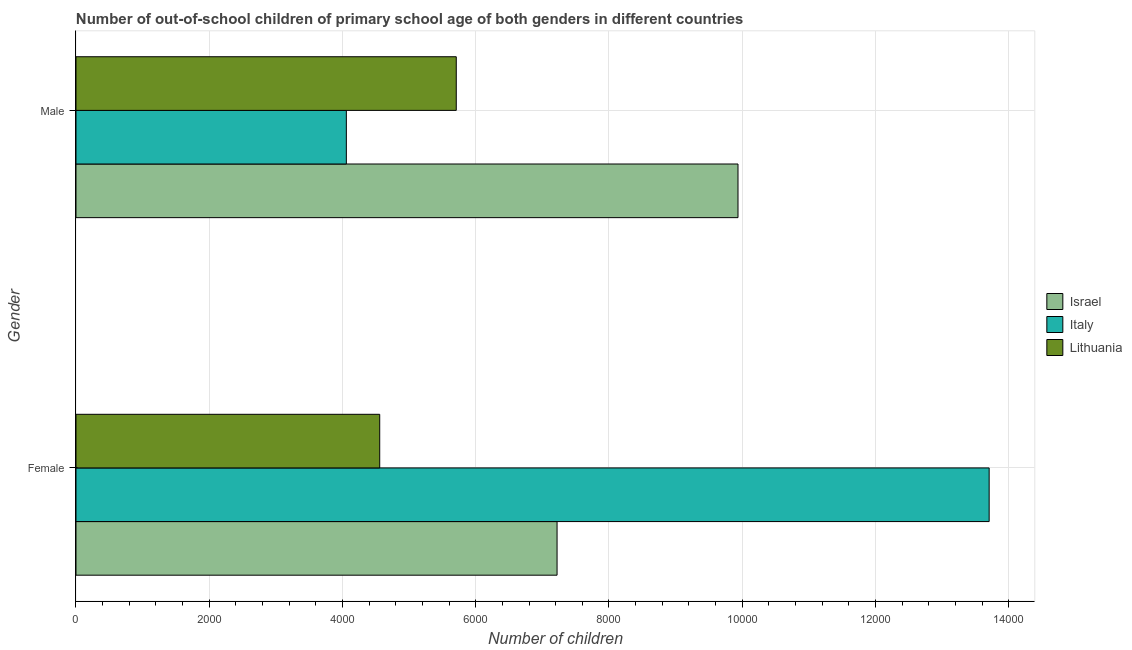How many groups of bars are there?
Your answer should be compact. 2. Are the number of bars per tick equal to the number of legend labels?
Give a very brief answer. Yes. How many bars are there on the 2nd tick from the top?
Make the answer very short. 3. What is the label of the 2nd group of bars from the top?
Provide a succinct answer. Female. What is the number of male out-of-school students in Italy?
Your answer should be compact. 4058. Across all countries, what is the maximum number of female out-of-school students?
Keep it short and to the point. 1.37e+04. Across all countries, what is the minimum number of female out-of-school students?
Make the answer very short. 4559. What is the total number of female out-of-school students in the graph?
Ensure brevity in your answer.  2.55e+04. What is the difference between the number of male out-of-school students in Israel and that in Lithuania?
Provide a short and direct response. 4229. What is the difference between the number of male out-of-school students in Italy and the number of female out-of-school students in Lithuania?
Ensure brevity in your answer.  -501. What is the average number of female out-of-school students per country?
Give a very brief answer. 8495.67. What is the difference between the number of male out-of-school students and number of female out-of-school students in Lithuania?
Offer a very short reply. 1149. In how many countries, is the number of male out-of-school students greater than 8000 ?
Provide a short and direct response. 1. What is the ratio of the number of female out-of-school students in Italy to that in Israel?
Give a very brief answer. 1.9. Is the number of male out-of-school students in Italy less than that in Israel?
Ensure brevity in your answer.  Yes. What does the 1st bar from the top in Male represents?
Ensure brevity in your answer.  Lithuania. How many bars are there?
Give a very brief answer. 6. How many countries are there in the graph?
Make the answer very short. 3. Are the values on the major ticks of X-axis written in scientific E-notation?
Provide a succinct answer. No. Does the graph contain any zero values?
Provide a succinct answer. No. Does the graph contain grids?
Your answer should be compact. Yes. What is the title of the graph?
Your response must be concise. Number of out-of-school children of primary school age of both genders in different countries. Does "Curacao" appear as one of the legend labels in the graph?
Give a very brief answer. No. What is the label or title of the X-axis?
Your answer should be very brief. Number of children. What is the Number of children of Israel in Female?
Your answer should be very brief. 7221. What is the Number of children in Italy in Female?
Offer a terse response. 1.37e+04. What is the Number of children in Lithuania in Female?
Make the answer very short. 4559. What is the Number of children in Israel in Male?
Make the answer very short. 9937. What is the Number of children of Italy in Male?
Provide a succinct answer. 4058. What is the Number of children of Lithuania in Male?
Provide a short and direct response. 5708. Across all Gender, what is the maximum Number of children of Israel?
Offer a terse response. 9937. Across all Gender, what is the maximum Number of children in Italy?
Make the answer very short. 1.37e+04. Across all Gender, what is the maximum Number of children of Lithuania?
Provide a short and direct response. 5708. Across all Gender, what is the minimum Number of children of Israel?
Provide a succinct answer. 7221. Across all Gender, what is the minimum Number of children of Italy?
Your answer should be compact. 4058. Across all Gender, what is the minimum Number of children in Lithuania?
Ensure brevity in your answer.  4559. What is the total Number of children in Israel in the graph?
Your answer should be compact. 1.72e+04. What is the total Number of children of Italy in the graph?
Ensure brevity in your answer.  1.78e+04. What is the total Number of children of Lithuania in the graph?
Offer a terse response. 1.03e+04. What is the difference between the Number of children of Israel in Female and that in Male?
Provide a short and direct response. -2716. What is the difference between the Number of children in Italy in Female and that in Male?
Offer a terse response. 9649. What is the difference between the Number of children of Lithuania in Female and that in Male?
Your response must be concise. -1149. What is the difference between the Number of children in Israel in Female and the Number of children in Italy in Male?
Make the answer very short. 3163. What is the difference between the Number of children of Israel in Female and the Number of children of Lithuania in Male?
Ensure brevity in your answer.  1513. What is the difference between the Number of children in Italy in Female and the Number of children in Lithuania in Male?
Provide a succinct answer. 7999. What is the average Number of children in Israel per Gender?
Provide a short and direct response. 8579. What is the average Number of children of Italy per Gender?
Your response must be concise. 8882.5. What is the average Number of children of Lithuania per Gender?
Provide a short and direct response. 5133.5. What is the difference between the Number of children in Israel and Number of children in Italy in Female?
Your response must be concise. -6486. What is the difference between the Number of children of Israel and Number of children of Lithuania in Female?
Your response must be concise. 2662. What is the difference between the Number of children in Italy and Number of children in Lithuania in Female?
Give a very brief answer. 9148. What is the difference between the Number of children of Israel and Number of children of Italy in Male?
Give a very brief answer. 5879. What is the difference between the Number of children in Israel and Number of children in Lithuania in Male?
Make the answer very short. 4229. What is the difference between the Number of children in Italy and Number of children in Lithuania in Male?
Provide a succinct answer. -1650. What is the ratio of the Number of children in Israel in Female to that in Male?
Your answer should be very brief. 0.73. What is the ratio of the Number of children in Italy in Female to that in Male?
Your answer should be very brief. 3.38. What is the ratio of the Number of children of Lithuania in Female to that in Male?
Make the answer very short. 0.8. What is the difference between the highest and the second highest Number of children in Israel?
Your response must be concise. 2716. What is the difference between the highest and the second highest Number of children of Italy?
Keep it short and to the point. 9649. What is the difference between the highest and the second highest Number of children of Lithuania?
Give a very brief answer. 1149. What is the difference between the highest and the lowest Number of children in Israel?
Your response must be concise. 2716. What is the difference between the highest and the lowest Number of children in Italy?
Your answer should be very brief. 9649. What is the difference between the highest and the lowest Number of children of Lithuania?
Provide a succinct answer. 1149. 